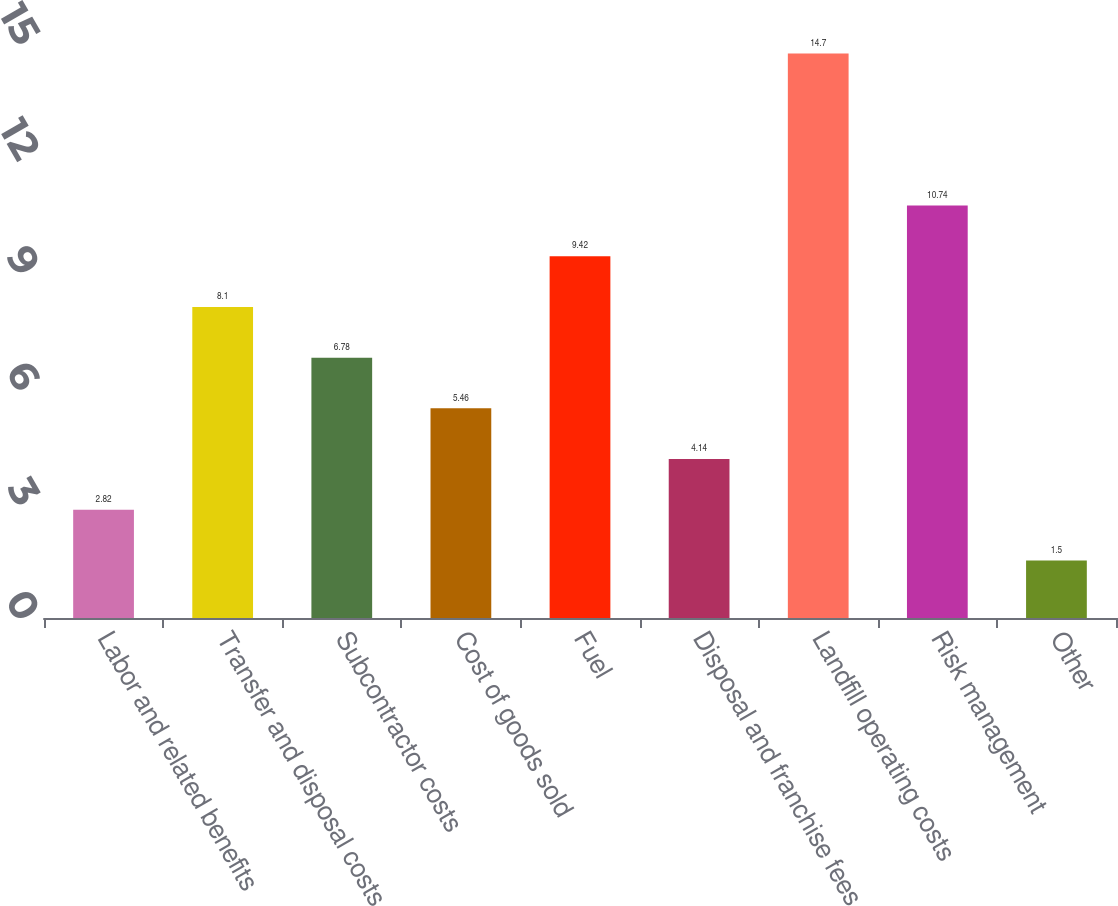Convert chart to OTSL. <chart><loc_0><loc_0><loc_500><loc_500><bar_chart><fcel>Labor and related benefits<fcel>Transfer and disposal costs<fcel>Subcontractor costs<fcel>Cost of goods sold<fcel>Fuel<fcel>Disposal and franchise fees<fcel>Landfill operating costs<fcel>Risk management<fcel>Other<nl><fcel>2.82<fcel>8.1<fcel>6.78<fcel>5.46<fcel>9.42<fcel>4.14<fcel>14.7<fcel>10.74<fcel>1.5<nl></chart> 